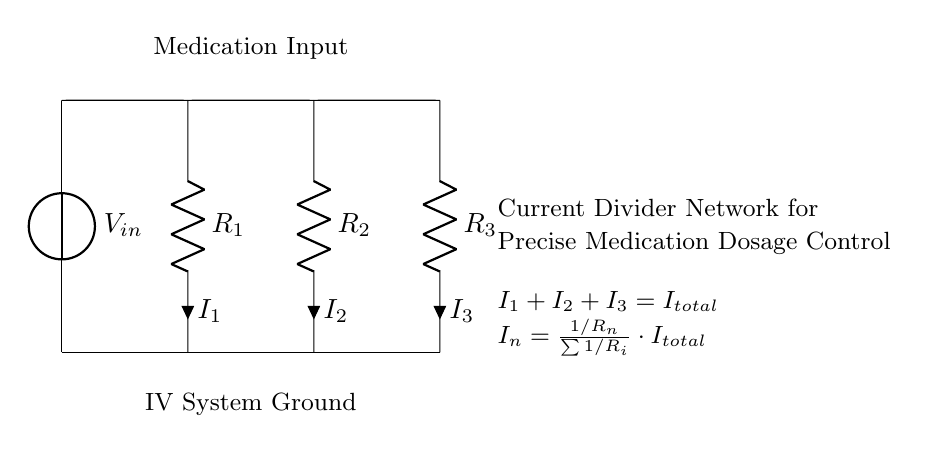What is the input voltage of this circuit? The input voltage, denoted as V_in, is the source voltage supplying the current divider network. It is represented as a voltage source connected at the top of the circuit diagram.
Answer: V_in What are the resistance values in the network? The circuit diagram shows three resistors: R1, R2, and R3. It does not specify their numeric values; only the labels are provided.
Answer: R1, R2, R3 What is the equation for the total current? The equation at the bottom of the circuit states that I_total equals the sum of the currents I1, I2, and I3 flowing through the resistors. This represents the total current entering the current divider.
Answer: I_total = I1 + I2 + I3 If R1 = 2 ohms and R2 = 3 ohms, what is I1 if I_total is 10 amperes? The current through R1 can be calculated using the current divider formula: I1 = (1/R1) / (1/R1 + 1/R2 + 1/R3) * I_total. With R3 assumed to be a resistor that affects the total resistance calculation, it needs inclusion. In this case, solving gives I1 = 4 amperes.
Answer: 4 amperes What does the equation I_n = (1/R_n)/(Σ1/R_i) * I_total represent? This equation defines the current through each resistor, I_n, as a fraction of the total current (I_total), based on the resistance values. It allows calculating how the input current is divided among the various branches of the circuit according to their resistance.
Answer: Current distribution formula Which component in the circuit is responsible for the variation in current distribution? The resistors R1, R2, and R3 determine how the total current is distributed in the circuit based on their individual resistance values. Their relative values dictate the amount of current flowing through each branch.
Answer: Resistors 